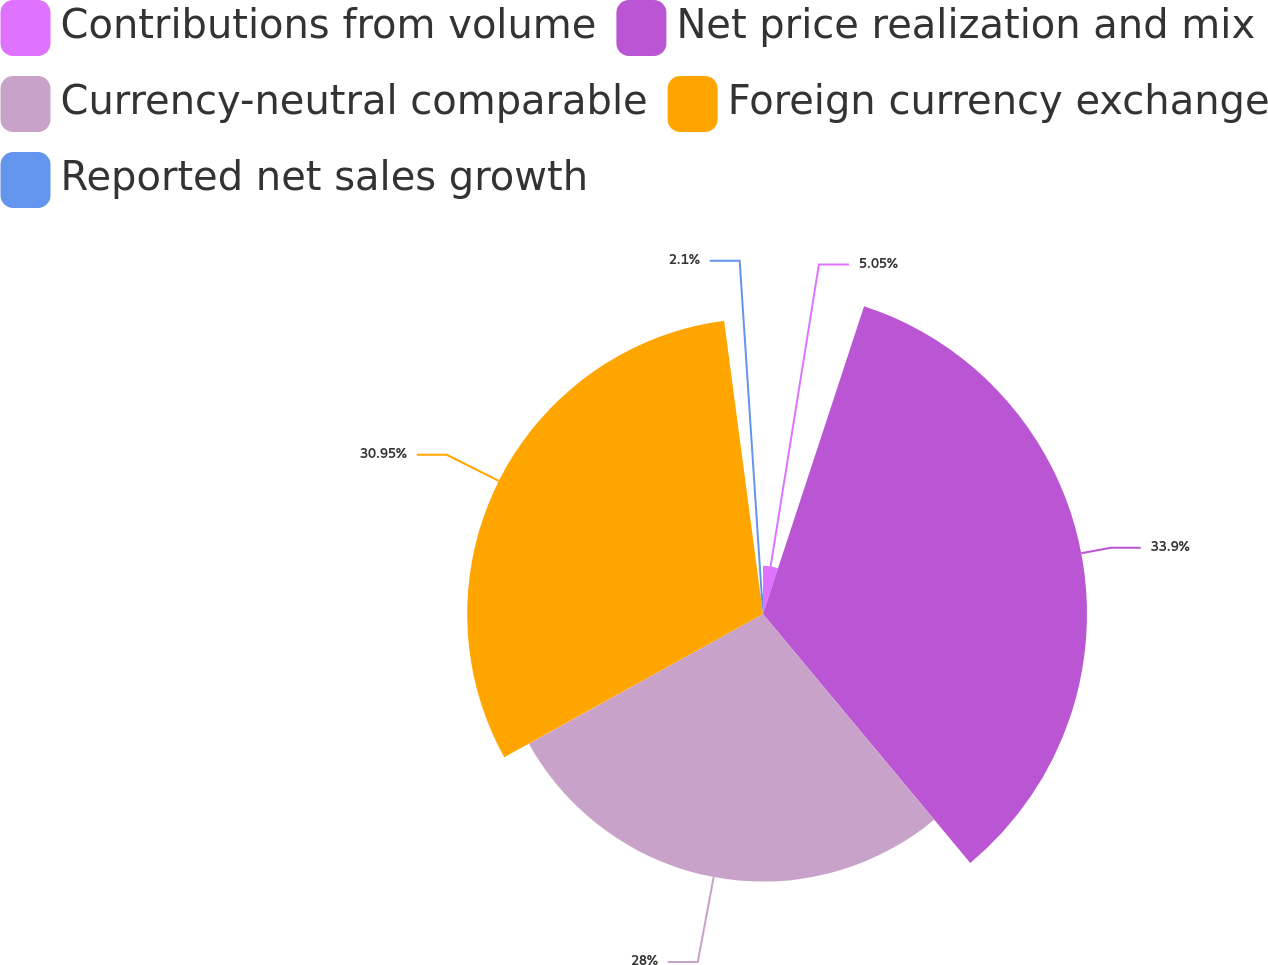<chart> <loc_0><loc_0><loc_500><loc_500><pie_chart><fcel>Contributions from volume<fcel>Net price realization and mix<fcel>Currency-neutral comparable<fcel>Foreign currency exchange<fcel>Reported net sales growth<nl><fcel>5.05%<fcel>33.9%<fcel>28.0%<fcel>30.95%<fcel>2.1%<nl></chart> 